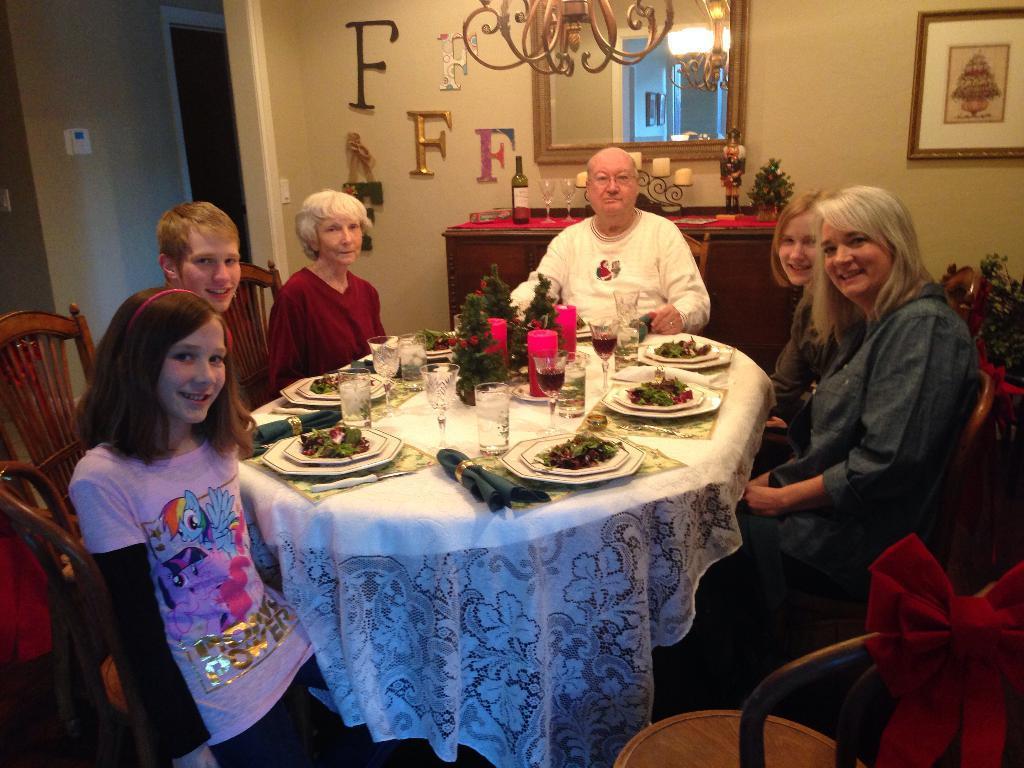Could you give a brief overview of what you see in this image? this picture shows a group of people sitting on the chairs and we see food in the plates and glasses and few plants on the table and we see a mirror and a wine bottle and couple of wine glasses and candles on the table and we see a photo frame on the wall and alphabet stickerings on the wall 